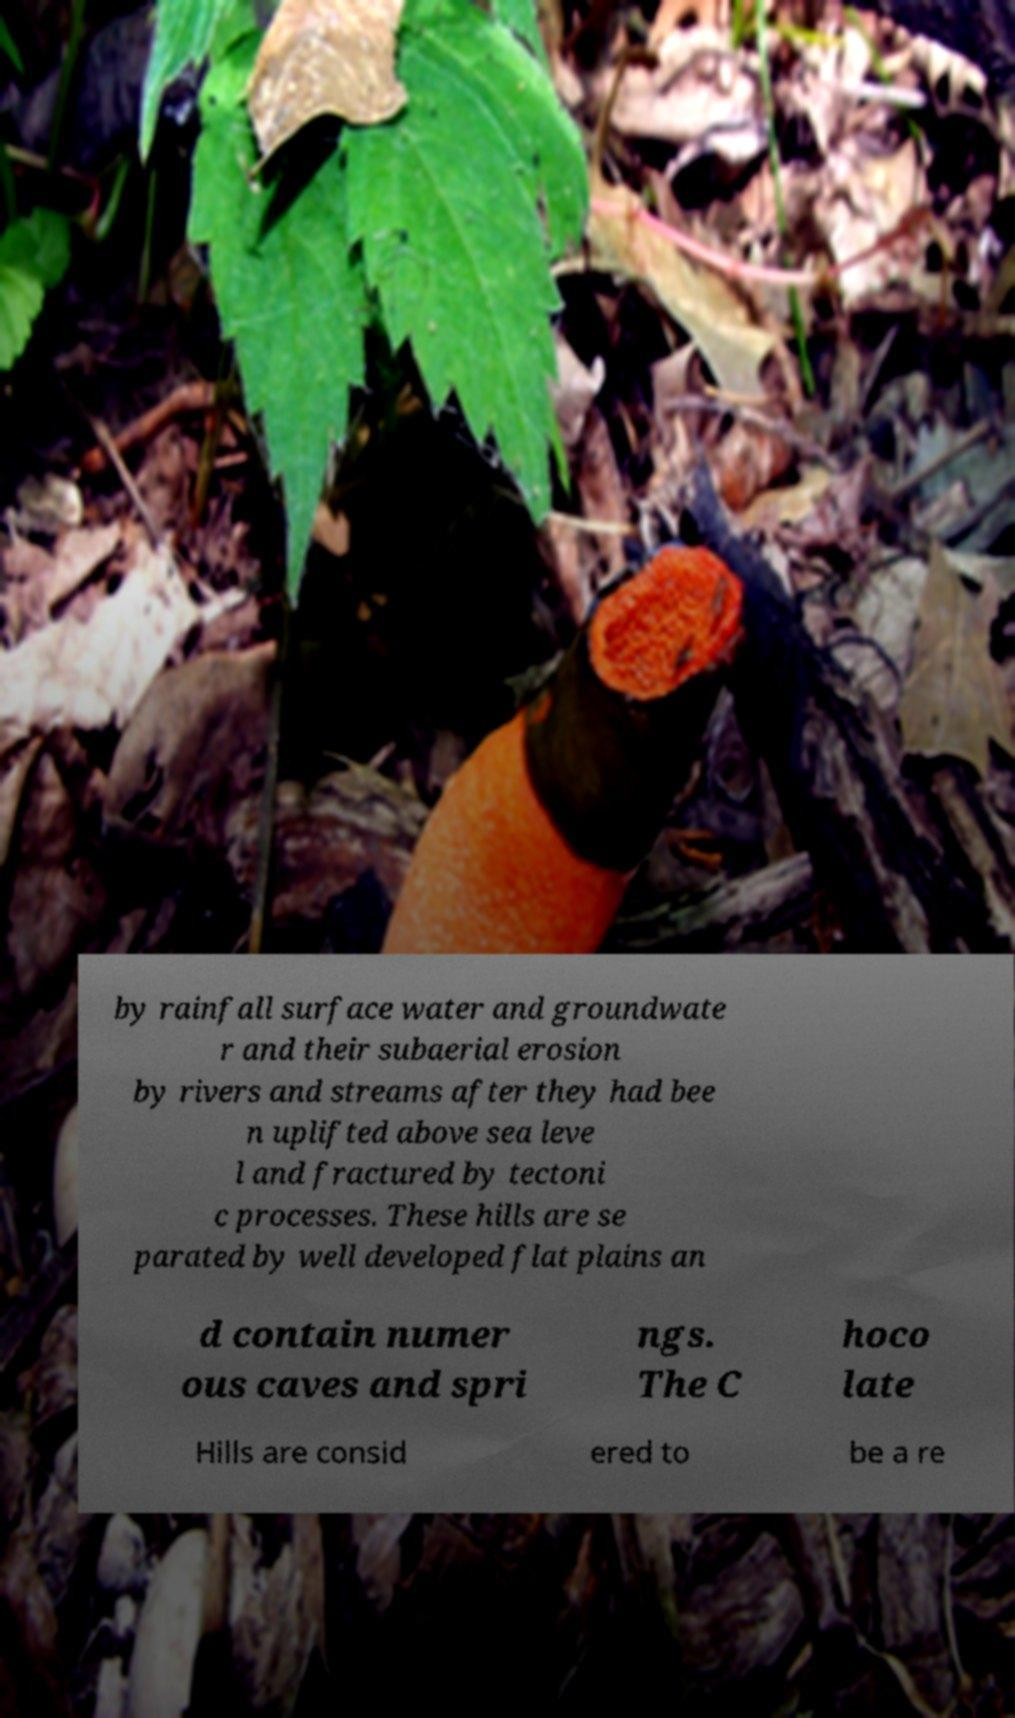Could you assist in decoding the text presented in this image and type it out clearly? by rainfall surface water and groundwate r and their subaerial erosion by rivers and streams after they had bee n uplifted above sea leve l and fractured by tectoni c processes. These hills are se parated by well developed flat plains an d contain numer ous caves and spri ngs. The C hoco late Hills are consid ered to be a re 